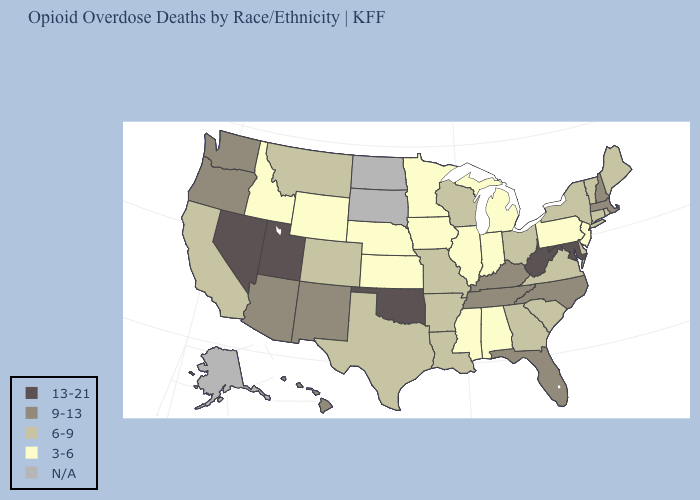What is the highest value in the USA?
Be succinct. 13-21. What is the value of Maryland?
Short answer required. 13-21. What is the value of Florida?
Answer briefly. 9-13. Does the map have missing data?
Answer briefly. Yes. What is the highest value in states that border Oklahoma?
Quick response, please. 9-13. Name the states that have a value in the range 6-9?
Quick response, please. Arkansas, California, Colorado, Connecticut, Delaware, Georgia, Louisiana, Maine, Missouri, Montana, New York, Ohio, Rhode Island, South Carolina, Texas, Vermont, Virginia, Wisconsin. What is the lowest value in the USA?
Short answer required. 3-6. Name the states that have a value in the range 9-13?
Answer briefly. Arizona, Florida, Hawaii, Kentucky, Massachusetts, New Hampshire, New Mexico, North Carolina, Oregon, Tennessee, Washington. What is the highest value in the USA?
Write a very short answer. 13-21. What is the value of Wyoming?
Quick response, please. 3-6. Does Nevada have the highest value in the USA?
Write a very short answer. Yes. Does New Jersey have the lowest value in the Northeast?
Quick response, please. Yes. 